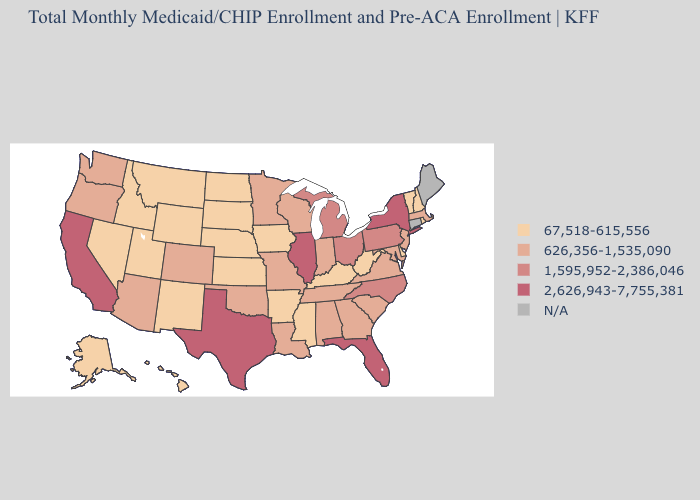Does the first symbol in the legend represent the smallest category?
Concise answer only. Yes. What is the highest value in states that border West Virginia?
Concise answer only. 1,595,952-2,386,046. Which states have the lowest value in the USA?
Concise answer only. Alaska, Arkansas, Delaware, Hawaii, Idaho, Iowa, Kansas, Kentucky, Mississippi, Montana, Nebraska, Nevada, New Hampshire, New Mexico, North Dakota, Rhode Island, South Dakota, Utah, Vermont, West Virginia, Wyoming. Name the states that have a value in the range 2,626,943-7,755,381?
Answer briefly. California, Florida, Illinois, New York, Texas. What is the value of New Hampshire?
Quick response, please. 67,518-615,556. Which states have the lowest value in the USA?
Give a very brief answer. Alaska, Arkansas, Delaware, Hawaii, Idaho, Iowa, Kansas, Kentucky, Mississippi, Montana, Nebraska, Nevada, New Hampshire, New Mexico, North Dakota, Rhode Island, South Dakota, Utah, Vermont, West Virginia, Wyoming. Name the states that have a value in the range 1,595,952-2,386,046?
Be succinct. Michigan, North Carolina, Ohio, Pennsylvania. What is the lowest value in the USA?
Concise answer only. 67,518-615,556. Which states have the lowest value in the Northeast?
Give a very brief answer. New Hampshire, Rhode Island, Vermont. What is the highest value in the West ?
Write a very short answer. 2,626,943-7,755,381. Name the states that have a value in the range 2,626,943-7,755,381?
Be succinct. California, Florida, Illinois, New York, Texas. Which states have the highest value in the USA?
Give a very brief answer. California, Florida, Illinois, New York, Texas. Name the states that have a value in the range 626,356-1,535,090?
Be succinct. Alabama, Arizona, Colorado, Georgia, Indiana, Louisiana, Maryland, Massachusetts, Minnesota, Missouri, New Jersey, Oklahoma, Oregon, South Carolina, Tennessee, Virginia, Washington, Wisconsin. Name the states that have a value in the range 67,518-615,556?
Answer briefly. Alaska, Arkansas, Delaware, Hawaii, Idaho, Iowa, Kansas, Kentucky, Mississippi, Montana, Nebraska, Nevada, New Hampshire, New Mexico, North Dakota, Rhode Island, South Dakota, Utah, Vermont, West Virginia, Wyoming. 